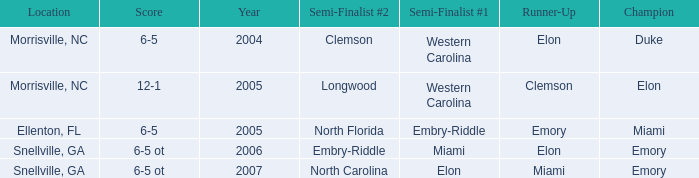When Embry-Riddle made it to the first semi finalist slot, list all the runners up. Emory. 